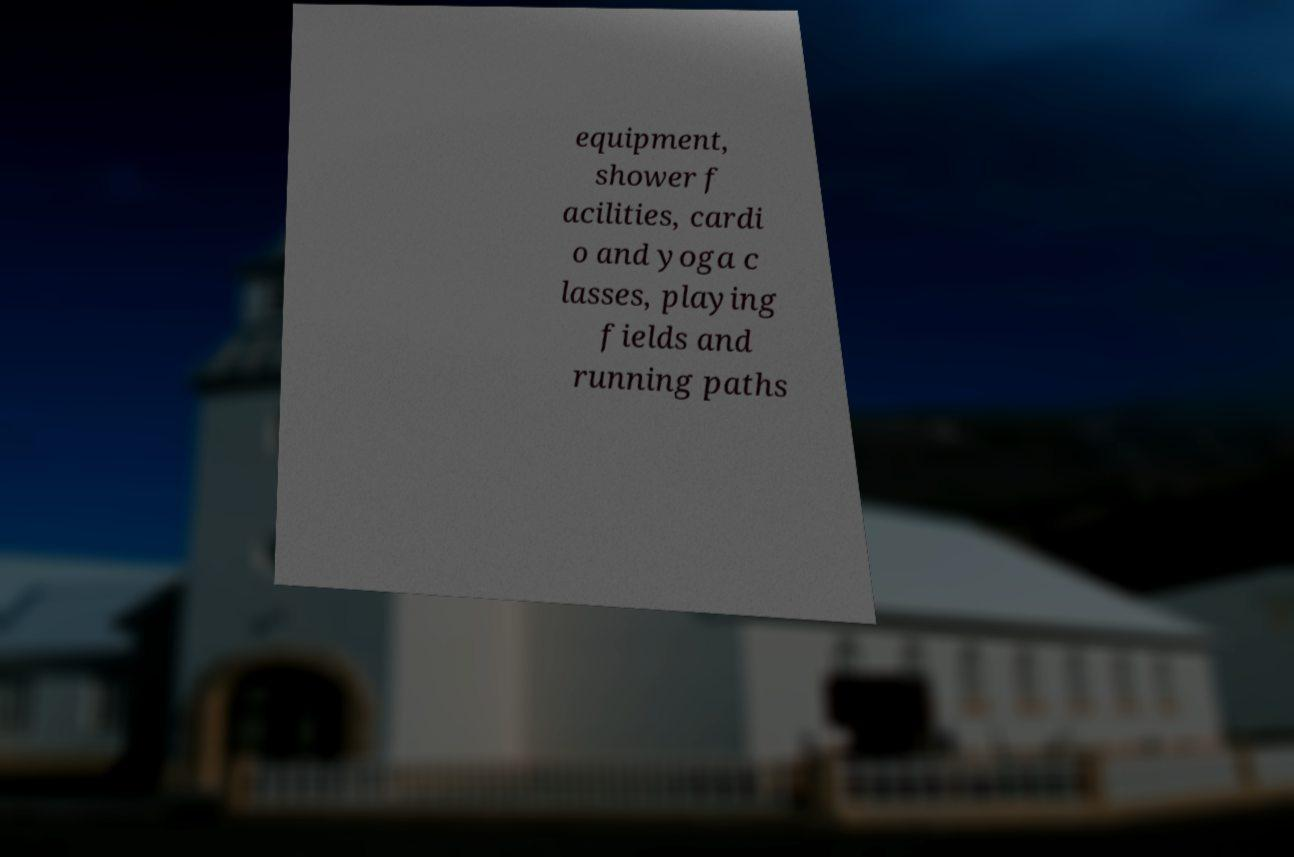Please read and relay the text visible in this image. What does it say? equipment, shower f acilities, cardi o and yoga c lasses, playing fields and running paths 